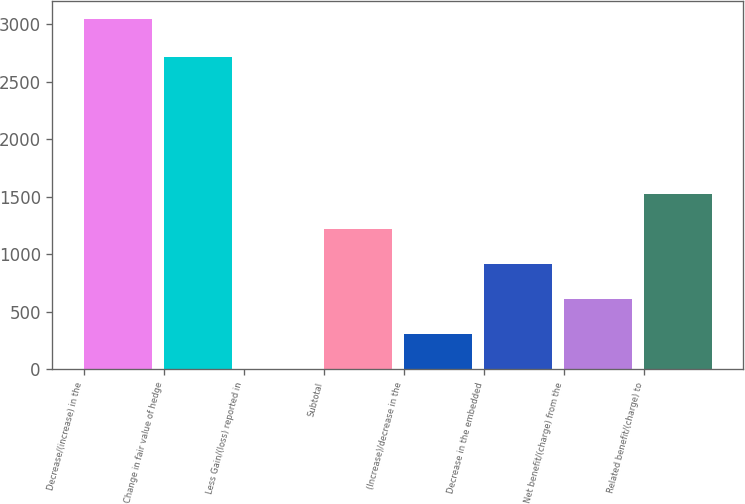Convert chart to OTSL. <chart><loc_0><loc_0><loc_500><loc_500><bar_chart><fcel>Decrease/(increase) in the<fcel>Change in fair value of hedge<fcel>Less Gain/(loss) reported in<fcel>Subtotal<fcel>(Increase)/decrease in the<fcel>Decrease in the embedded<fcel>Net benefit/(charge) from the<fcel>Related benefit/(charge) to<nl><fcel>3049<fcel>2715<fcel>1.74<fcel>1220.66<fcel>306.47<fcel>915.93<fcel>611.2<fcel>1525.39<nl></chart> 